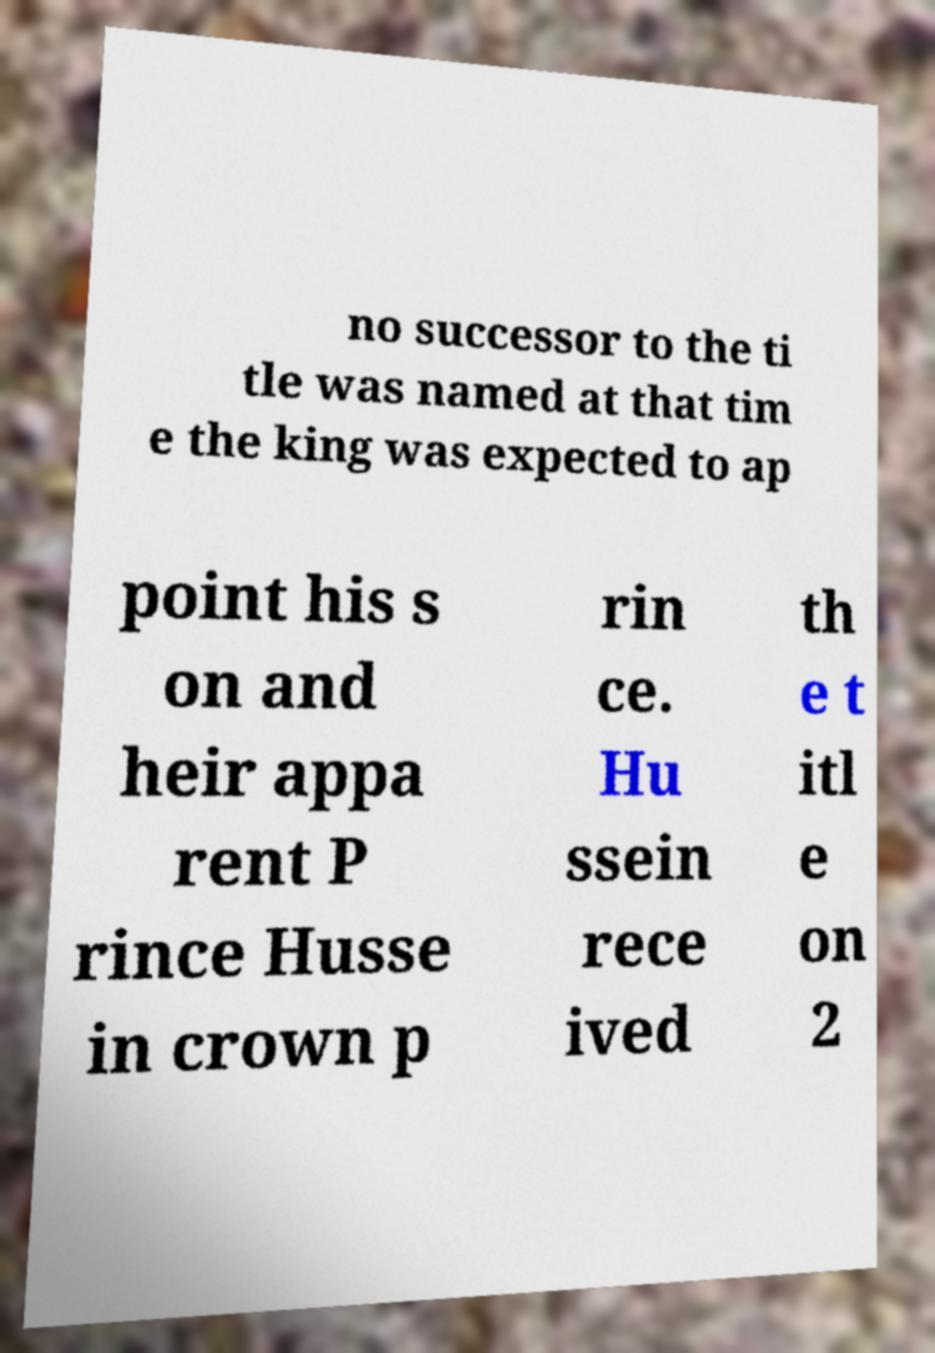Please identify and transcribe the text found in this image. no successor to the ti tle was named at that tim e the king was expected to ap point his s on and heir appa rent P rince Husse in crown p rin ce. Hu ssein rece ived th e t itl e on 2 